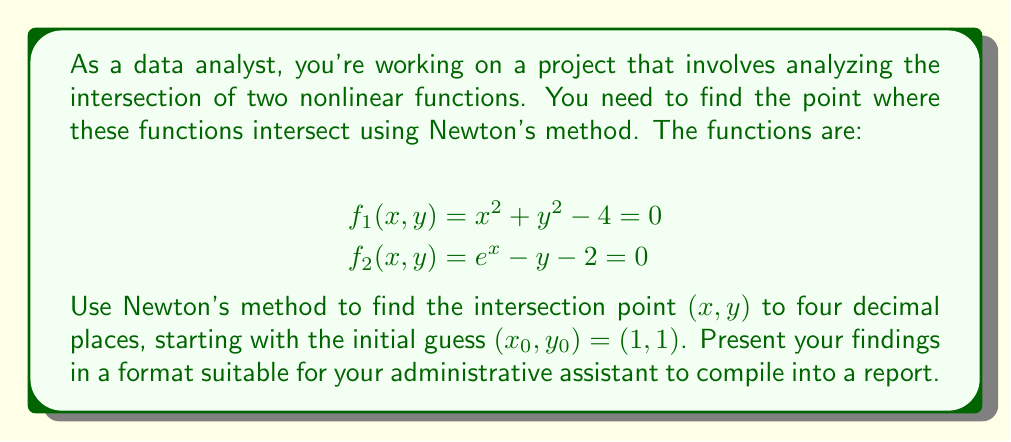Can you answer this question? To solve this system using Newton's method, we follow these steps:

1) Define the system of equations:
   $$F(x, y) = \begin{bmatrix} f_1(x, y) \\ f_2(x, y) \end{bmatrix} = \begin{bmatrix} x^2 + y^2 - 4 \\ e^x - y - 2 \end{bmatrix}$$

2) Calculate the Jacobian matrix:
   $$J(x, y) = \begin{bmatrix} \frac{\partial f_1}{\partial x} & \frac{\partial f_1}{\partial y} \\ \frac{\partial f_2}{\partial x} & \frac{\partial f_2}{\partial y} \end{bmatrix} = \begin{bmatrix} 2x & 2y \\ e^x & -1 \end{bmatrix}$$

3) Newton's method iteration:
   $$\begin{bmatrix} x_{n+1} \\ y_{n+1} \end{bmatrix} = \begin{bmatrix} x_n \\ y_n \end{bmatrix} - J(x_n, y_n)^{-1} F(x_n, y_n)$$

4) Start with $(x_0, y_0) = (1, 1)$ and iterate:

   Iteration 1:
   $$F(1, 1) = \begin{bmatrix} 1^2 + 1^2 - 4 \\ e^1 - 1 - 2 \end{bmatrix} = \begin{bmatrix} -2 \\ -0.2817 \end{bmatrix}$$
   $$J(1, 1) = \begin{bmatrix} 2 & 2 \\ e & -1 \end{bmatrix}$$
   $$J(1, 1)^{-1} = \frac{1}{2+2e} \begin{bmatrix} -1 & -2 \\ -e & 2 \end{bmatrix}$$
   $$\begin{bmatrix} x_1 \\ y_1 \end{bmatrix} = \begin{bmatrix} 1 \\ 1 \end{bmatrix} - \frac{1}{2+2e} \begin{bmatrix} -1 & -2 \\ -e & 2 \end{bmatrix} \begin{bmatrix} -2 \\ -0.2817 \end{bmatrix} = \begin{bmatrix} 1.4453 \\ 1.2490 \end{bmatrix}$$

   Iteration 2:
   $$F(1.4453, 1.2490) = \begin{bmatrix} -0.0881 \\ 0.0030 \end{bmatrix}$$
   $$J(1.4453, 1.2490) = \begin{bmatrix} 2.8906 & 2.4980 \\ 4.2433 & -1 \end{bmatrix}$$
   $$\begin{bmatrix} x_2 \\ y_2 \end{bmatrix} = \begin{bmatrix} 1.4641 \\ 1.2361 \end{bmatrix}$$

   Iteration 3:
   $$F(1.4641, 1.2361) = \begin{bmatrix} -0.0002 \\ 0.0000 \end{bmatrix}$$
   $$J(1.4641, 1.2361) = \begin{bmatrix} 2.9282 & 2.4722 \\ 4.3238 & -1 \end{bmatrix}$$
   $$\begin{bmatrix} x_3 \\ y_3 \end{bmatrix} = \begin{bmatrix} 1.4642 \\ 1.2361 \end{bmatrix}$$

5) The solution converges to four decimal places after three iterations.
Answer: $(x, y) = (1.4642, 1.2361)$ 